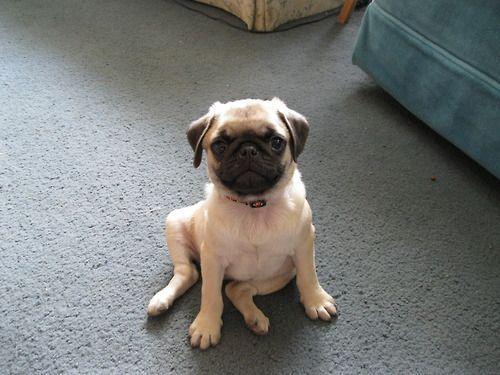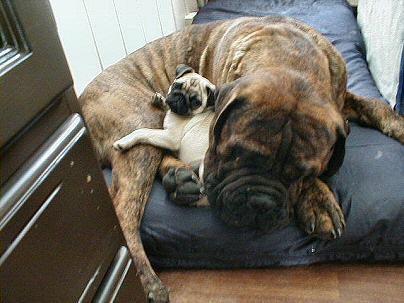The first image is the image on the left, the second image is the image on the right. Evaluate the accuracy of this statement regarding the images: "One image shows a camera-facing sitting pug with something bright blue hanging downward from its neck.". Is it true? Answer yes or no. No. The first image is the image on the left, the second image is the image on the right. Considering the images on both sides, is "Only the dog in the image on the left is wearing a collar." valid? Answer yes or no. Yes. 